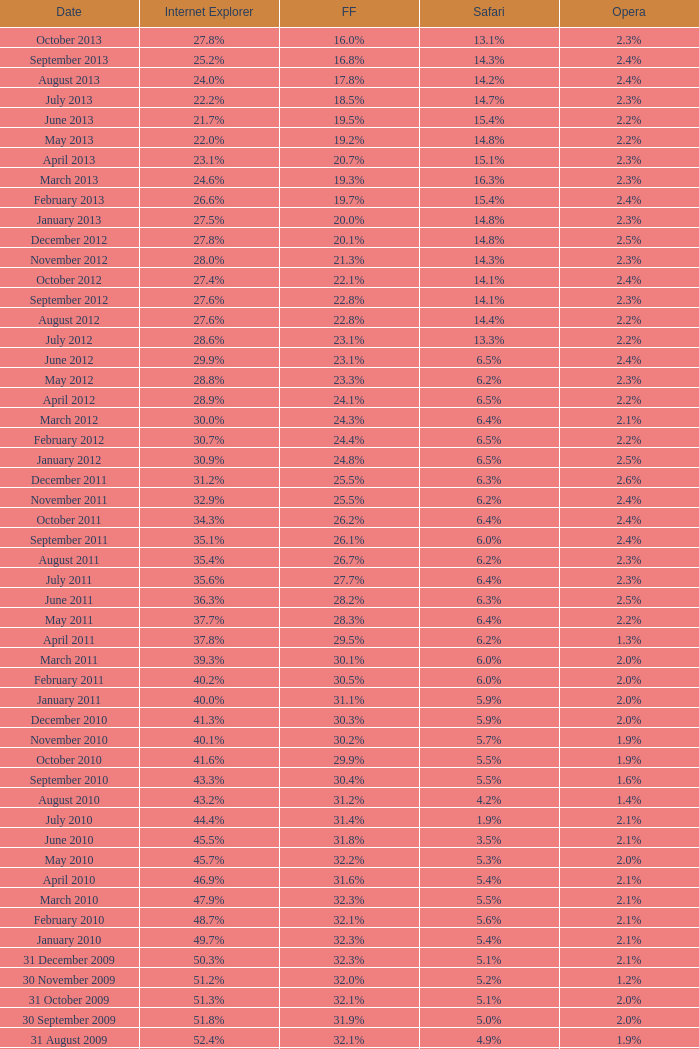Can you give me this table as a dict? {'header': ['Date', 'Internet Explorer', 'FF', 'Safari', 'Opera'], 'rows': [['October 2013', '27.8%', '16.0%', '13.1%', '2.3%'], ['September 2013', '25.2%', '16.8%', '14.3%', '2.4%'], ['August 2013', '24.0%', '17.8%', '14.2%', '2.4%'], ['July 2013', '22.2%', '18.5%', '14.7%', '2.3%'], ['June 2013', '21.7%', '19.5%', '15.4%', '2.2%'], ['May 2013', '22.0%', '19.2%', '14.8%', '2.2%'], ['April 2013', '23.1%', '20.7%', '15.1%', '2.3%'], ['March 2013', '24.6%', '19.3%', '16.3%', '2.3%'], ['February 2013', '26.6%', '19.7%', '15.4%', '2.4%'], ['January 2013', '27.5%', '20.0%', '14.8%', '2.3%'], ['December 2012', '27.8%', '20.1%', '14.8%', '2.5%'], ['November 2012', '28.0%', '21.3%', '14.3%', '2.3%'], ['October 2012', '27.4%', '22.1%', '14.1%', '2.4%'], ['September 2012', '27.6%', '22.8%', '14.1%', '2.3%'], ['August 2012', '27.6%', '22.8%', '14.4%', '2.2%'], ['July 2012', '28.6%', '23.1%', '13.3%', '2.2%'], ['June 2012', '29.9%', '23.1%', '6.5%', '2.4%'], ['May 2012', '28.8%', '23.3%', '6.2%', '2.3%'], ['April 2012', '28.9%', '24.1%', '6.5%', '2.2%'], ['March 2012', '30.0%', '24.3%', '6.4%', '2.1%'], ['February 2012', '30.7%', '24.4%', '6.5%', '2.2%'], ['January 2012', '30.9%', '24.8%', '6.5%', '2.5%'], ['December 2011', '31.2%', '25.5%', '6.3%', '2.6%'], ['November 2011', '32.9%', '25.5%', '6.2%', '2.4%'], ['October 2011', '34.3%', '26.2%', '6.4%', '2.4%'], ['September 2011', '35.1%', '26.1%', '6.0%', '2.4%'], ['August 2011', '35.4%', '26.7%', '6.2%', '2.3%'], ['July 2011', '35.6%', '27.7%', '6.4%', '2.3%'], ['June 2011', '36.3%', '28.2%', '6.3%', '2.5%'], ['May 2011', '37.7%', '28.3%', '6.4%', '2.2%'], ['April 2011', '37.8%', '29.5%', '6.2%', '1.3%'], ['March 2011', '39.3%', '30.1%', '6.0%', '2.0%'], ['February 2011', '40.2%', '30.5%', '6.0%', '2.0%'], ['January 2011', '40.0%', '31.1%', '5.9%', '2.0%'], ['December 2010', '41.3%', '30.3%', '5.9%', '2.0%'], ['November 2010', '40.1%', '30.2%', '5.7%', '1.9%'], ['October 2010', '41.6%', '29.9%', '5.5%', '1.9%'], ['September 2010', '43.3%', '30.4%', '5.5%', '1.6%'], ['August 2010', '43.2%', '31.2%', '4.2%', '1.4%'], ['July 2010', '44.4%', '31.4%', '1.9%', '2.1%'], ['June 2010', '45.5%', '31.8%', '3.5%', '2.1%'], ['May 2010', '45.7%', '32.2%', '5.3%', '2.0%'], ['April 2010', '46.9%', '31.6%', '5.4%', '2.1%'], ['March 2010', '47.9%', '32.3%', '5.5%', '2.1%'], ['February 2010', '48.7%', '32.1%', '5.6%', '2.1%'], ['January 2010', '49.7%', '32.3%', '5.4%', '2.1%'], ['31 December 2009', '50.3%', '32.3%', '5.1%', '2.1%'], ['30 November 2009', '51.2%', '32.0%', '5.2%', '1.2%'], ['31 October 2009', '51.3%', '32.1%', '5.1%', '2.0%'], ['30 September 2009', '51.8%', '31.9%', '5.0%', '2.0%'], ['31 August 2009', '52.4%', '32.1%', '4.9%', '1.9%'], ['31 July 2009', '53.1%', '31.7%', '4.6%', '1.8%'], ['30 June 2009', '57.1%', '31.6%', '3.2%', '2.0%'], ['31 May 2009', '57.5%', '31.4%', '3.1%', '2.0%'], ['30 April 2009', '57.6%', '31.6%', '2.9%', '2.0%'], ['31 March 2009', '57.8%', '31.5%', '2.8%', '2.0%'], ['28 February 2009', '58.1%', '31.3%', '2.7%', '2.0%'], ['31 January 2009', '58.4%', '31.1%', '2.7%', '2.0%'], ['31 December 2008', '58.6%', '31.1%', '2.9%', '2.1%'], ['30 November 2008', '59.0%', '30.8%', '3.0%', '2.0%'], ['31 October 2008', '59.4%', '30.6%', '3.0%', '2.0%'], ['30 September 2008', '57.3%', '32.5%', '2.7%', '2.0%'], ['31 August 2008', '58.7%', '31.4%', '2.4%', '2.1%'], ['31 July 2008', '60.9%', '29.7%', '2.4%', '2.0%'], ['30 June 2008', '61.7%', '29.1%', '2.5%', '2.0%'], ['31 May 2008', '61.9%', '28.9%', '2.7%', '2.0%'], ['30 April 2008', '62.0%', '28.8%', '2.8%', '2.0%'], ['31 March 2008', '62.0%', '28.8%', '2.8%', '2.0%'], ['29 February 2008', '62.0%', '28.7%', '2.8%', '2.0%'], ['31 January 2008', '62.2%', '28.7%', '2.7%', '2.0%'], ['1 December 2007', '62.8%', '28.0%', '2.6%', '2.0%'], ['10 November 2007', '63.0%', '27.8%', '2.5%', '2.0%'], ['30 October 2007', '65.5%', '26.3%', '2.3%', '1.8%'], ['20 September 2007', '66.6%', '25.6%', '2.1%', '1.8%'], ['30 August 2007', '66.7%', '25.5%', '2.1%', '1.8%'], ['30 July 2007', '66.9%', '25.1%', '2.2%', '1.8%'], ['30 June 2007', '66.9%', '25.1%', '2.3%', '1.8%'], ['30 May 2007', '67.1%', '24.8%', '2.4%', '1.8%'], ['Date', 'Internet Explorer', 'Firefox', 'Safari', 'Opera']]} What is the date when internet explorer was 62.2% 31 January 2008. 